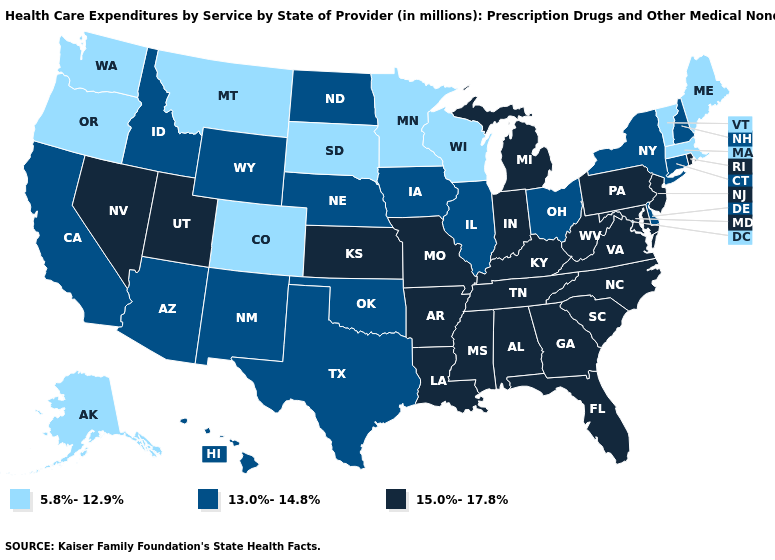Does Missouri have the lowest value in the USA?
Short answer required. No. Name the states that have a value in the range 15.0%-17.8%?
Concise answer only. Alabama, Arkansas, Florida, Georgia, Indiana, Kansas, Kentucky, Louisiana, Maryland, Michigan, Mississippi, Missouri, Nevada, New Jersey, North Carolina, Pennsylvania, Rhode Island, South Carolina, Tennessee, Utah, Virginia, West Virginia. Name the states that have a value in the range 5.8%-12.9%?
Answer briefly. Alaska, Colorado, Maine, Massachusetts, Minnesota, Montana, Oregon, South Dakota, Vermont, Washington, Wisconsin. Which states have the lowest value in the South?
Give a very brief answer. Delaware, Oklahoma, Texas. What is the lowest value in the Northeast?
Short answer required. 5.8%-12.9%. What is the value of Iowa?
Quick response, please. 13.0%-14.8%. What is the value of Colorado?
Keep it brief. 5.8%-12.9%. Does Kansas have a higher value than South Carolina?
Concise answer only. No. What is the highest value in the USA?
Concise answer only. 15.0%-17.8%. Does the first symbol in the legend represent the smallest category?
Keep it brief. Yes. Does the map have missing data?
Answer briefly. No. Name the states that have a value in the range 13.0%-14.8%?
Give a very brief answer. Arizona, California, Connecticut, Delaware, Hawaii, Idaho, Illinois, Iowa, Nebraska, New Hampshire, New Mexico, New York, North Dakota, Ohio, Oklahoma, Texas, Wyoming. Name the states that have a value in the range 13.0%-14.8%?
Quick response, please. Arizona, California, Connecticut, Delaware, Hawaii, Idaho, Illinois, Iowa, Nebraska, New Hampshire, New Mexico, New York, North Dakota, Ohio, Oklahoma, Texas, Wyoming. 